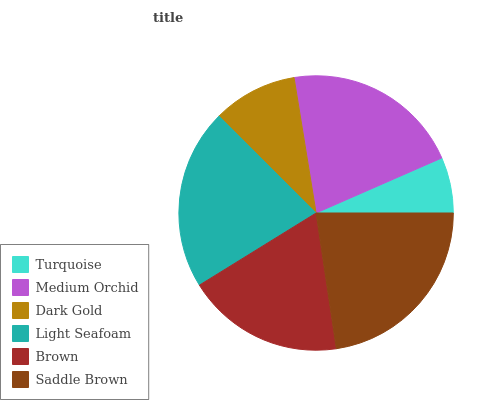Is Turquoise the minimum?
Answer yes or no. Yes. Is Saddle Brown the maximum?
Answer yes or no. Yes. Is Medium Orchid the minimum?
Answer yes or no. No. Is Medium Orchid the maximum?
Answer yes or no. No. Is Medium Orchid greater than Turquoise?
Answer yes or no. Yes. Is Turquoise less than Medium Orchid?
Answer yes or no. Yes. Is Turquoise greater than Medium Orchid?
Answer yes or no. No. Is Medium Orchid less than Turquoise?
Answer yes or no. No. Is Medium Orchid the high median?
Answer yes or no. Yes. Is Brown the low median?
Answer yes or no. Yes. Is Turquoise the high median?
Answer yes or no. No. Is Light Seafoam the low median?
Answer yes or no. No. 